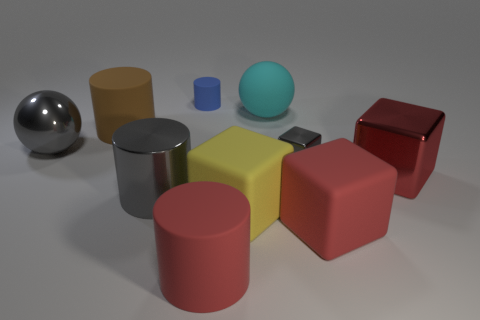Subtract all large yellow cubes. How many cubes are left? 3 Subtract all gray spheres. How many spheres are left? 1 Subtract 1 cylinders. How many cylinders are left? 3 Subtract all green cylinders. Subtract all gray spheres. How many cylinders are left? 4 Subtract all gray cubes. How many gray cylinders are left? 1 Subtract all small brown shiny objects. Subtract all large gray metallic cylinders. How many objects are left? 9 Add 8 red matte cylinders. How many red matte cylinders are left? 9 Add 2 tiny metallic spheres. How many tiny metallic spheres exist? 2 Subtract 1 yellow blocks. How many objects are left? 9 Subtract all cubes. How many objects are left? 6 